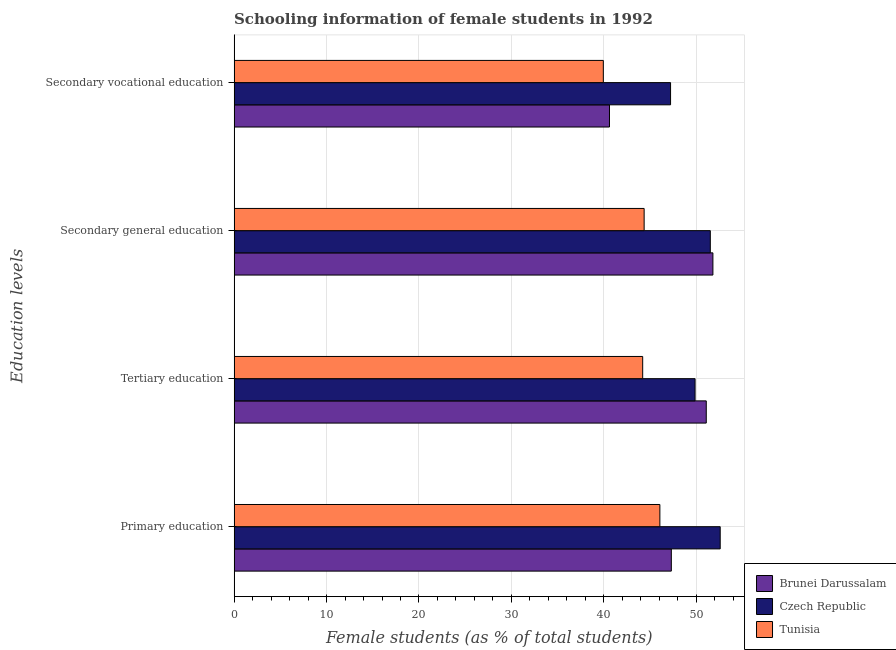How many different coloured bars are there?
Give a very brief answer. 3. How many bars are there on the 1st tick from the bottom?
Provide a succinct answer. 3. What is the percentage of female students in tertiary education in Brunei Darussalam?
Offer a terse response. 51.09. Across all countries, what is the maximum percentage of female students in secondary education?
Your response must be concise. 51.81. Across all countries, what is the minimum percentage of female students in tertiary education?
Keep it short and to the point. 44.21. In which country was the percentage of female students in tertiary education maximum?
Ensure brevity in your answer.  Brunei Darussalam. In which country was the percentage of female students in secondary education minimum?
Your answer should be very brief. Tunisia. What is the total percentage of female students in secondary education in the graph?
Your answer should be very brief. 147.7. What is the difference between the percentage of female students in tertiary education in Czech Republic and that in Tunisia?
Ensure brevity in your answer.  5.67. What is the difference between the percentage of female students in secondary education in Brunei Darussalam and the percentage of female students in primary education in Czech Republic?
Your response must be concise. -0.79. What is the average percentage of female students in secondary education per country?
Offer a very short reply. 49.23. What is the difference between the percentage of female students in secondary vocational education and percentage of female students in primary education in Czech Republic?
Offer a very short reply. -5.37. In how many countries, is the percentage of female students in secondary vocational education greater than 52 %?
Your answer should be very brief. 0. What is the ratio of the percentage of female students in secondary vocational education in Tunisia to that in Brunei Darussalam?
Offer a terse response. 0.98. Is the percentage of female students in tertiary education in Brunei Darussalam less than that in Tunisia?
Provide a succinct answer. No. Is the difference between the percentage of female students in secondary education in Brunei Darussalam and Czech Republic greater than the difference between the percentage of female students in primary education in Brunei Darussalam and Czech Republic?
Provide a succinct answer. Yes. What is the difference between the highest and the second highest percentage of female students in primary education?
Make the answer very short. 5.29. What is the difference between the highest and the lowest percentage of female students in secondary vocational education?
Your response must be concise. 7.28. What does the 1st bar from the top in Secondary general education represents?
Your response must be concise. Tunisia. What does the 3rd bar from the bottom in Tertiary education represents?
Your answer should be very brief. Tunisia. Are all the bars in the graph horizontal?
Provide a succinct answer. Yes. What is the difference between two consecutive major ticks on the X-axis?
Your answer should be compact. 10. Does the graph contain any zero values?
Your answer should be very brief. No. Where does the legend appear in the graph?
Provide a short and direct response. Bottom right. How many legend labels are there?
Provide a succinct answer. 3. What is the title of the graph?
Give a very brief answer. Schooling information of female students in 1992. What is the label or title of the X-axis?
Your answer should be very brief. Female students (as % of total students). What is the label or title of the Y-axis?
Provide a short and direct response. Education levels. What is the Female students (as % of total students) of Brunei Darussalam in Primary education?
Provide a succinct answer. 47.31. What is the Female students (as % of total students) of Czech Republic in Primary education?
Your response must be concise. 52.6. What is the Female students (as % of total students) in Tunisia in Primary education?
Offer a terse response. 46.07. What is the Female students (as % of total students) in Brunei Darussalam in Tertiary education?
Keep it short and to the point. 51.09. What is the Female students (as % of total students) of Czech Republic in Tertiary education?
Keep it short and to the point. 49.88. What is the Female students (as % of total students) in Tunisia in Tertiary education?
Offer a very short reply. 44.21. What is the Female students (as % of total students) of Brunei Darussalam in Secondary general education?
Provide a succinct answer. 51.81. What is the Female students (as % of total students) in Czech Republic in Secondary general education?
Provide a short and direct response. 51.52. What is the Female students (as % of total students) in Tunisia in Secondary general education?
Provide a short and direct response. 44.37. What is the Female students (as % of total students) of Brunei Darussalam in Secondary vocational education?
Offer a very short reply. 40.62. What is the Female students (as % of total students) in Czech Republic in Secondary vocational education?
Offer a terse response. 47.22. What is the Female students (as % of total students) in Tunisia in Secondary vocational education?
Ensure brevity in your answer.  39.95. Across all Education levels, what is the maximum Female students (as % of total students) of Brunei Darussalam?
Your answer should be very brief. 51.81. Across all Education levels, what is the maximum Female students (as % of total students) of Czech Republic?
Offer a terse response. 52.6. Across all Education levels, what is the maximum Female students (as % of total students) of Tunisia?
Ensure brevity in your answer.  46.07. Across all Education levels, what is the minimum Female students (as % of total students) of Brunei Darussalam?
Keep it short and to the point. 40.62. Across all Education levels, what is the minimum Female students (as % of total students) of Czech Republic?
Your response must be concise. 47.22. Across all Education levels, what is the minimum Female students (as % of total students) of Tunisia?
Ensure brevity in your answer.  39.95. What is the total Female students (as % of total students) in Brunei Darussalam in the graph?
Offer a very short reply. 190.82. What is the total Female students (as % of total students) in Czech Republic in the graph?
Your answer should be very brief. 201.22. What is the total Female students (as % of total students) of Tunisia in the graph?
Make the answer very short. 174.59. What is the difference between the Female students (as % of total students) of Brunei Darussalam in Primary education and that in Tertiary education?
Provide a short and direct response. -3.78. What is the difference between the Female students (as % of total students) in Czech Republic in Primary education and that in Tertiary education?
Your answer should be very brief. 2.72. What is the difference between the Female students (as % of total students) of Tunisia in Primary education and that in Tertiary education?
Ensure brevity in your answer.  1.86. What is the difference between the Female students (as % of total students) in Brunei Darussalam in Primary education and that in Secondary general education?
Provide a succinct answer. -4.5. What is the difference between the Female students (as % of total students) in Czech Republic in Primary education and that in Secondary general education?
Your answer should be compact. 1.07. What is the difference between the Female students (as % of total students) in Tunisia in Primary education and that in Secondary general education?
Provide a succinct answer. 1.7. What is the difference between the Female students (as % of total students) of Brunei Darussalam in Primary education and that in Secondary vocational education?
Provide a succinct answer. 6.69. What is the difference between the Female students (as % of total students) of Czech Republic in Primary education and that in Secondary vocational education?
Your answer should be very brief. 5.37. What is the difference between the Female students (as % of total students) in Tunisia in Primary education and that in Secondary vocational education?
Keep it short and to the point. 6.12. What is the difference between the Female students (as % of total students) in Brunei Darussalam in Tertiary education and that in Secondary general education?
Your answer should be compact. -0.72. What is the difference between the Female students (as % of total students) of Czech Republic in Tertiary education and that in Secondary general education?
Make the answer very short. -1.65. What is the difference between the Female students (as % of total students) in Tunisia in Tertiary education and that in Secondary general education?
Your answer should be very brief. -0.16. What is the difference between the Female students (as % of total students) of Brunei Darussalam in Tertiary education and that in Secondary vocational education?
Your response must be concise. 10.47. What is the difference between the Female students (as % of total students) in Czech Republic in Tertiary education and that in Secondary vocational education?
Make the answer very short. 2.65. What is the difference between the Female students (as % of total students) in Tunisia in Tertiary education and that in Secondary vocational education?
Offer a terse response. 4.26. What is the difference between the Female students (as % of total students) of Brunei Darussalam in Secondary general education and that in Secondary vocational education?
Your response must be concise. 11.19. What is the difference between the Female students (as % of total students) in Czech Republic in Secondary general education and that in Secondary vocational education?
Provide a succinct answer. 4.3. What is the difference between the Female students (as % of total students) in Tunisia in Secondary general education and that in Secondary vocational education?
Provide a short and direct response. 4.42. What is the difference between the Female students (as % of total students) in Brunei Darussalam in Primary education and the Female students (as % of total students) in Czech Republic in Tertiary education?
Provide a short and direct response. -2.57. What is the difference between the Female students (as % of total students) of Brunei Darussalam in Primary education and the Female students (as % of total students) of Tunisia in Tertiary education?
Ensure brevity in your answer.  3.1. What is the difference between the Female students (as % of total students) in Czech Republic in Primary education and the Female students (as % of total students) in Tunisia in Tertiary education?
Provide a succinct answer. 8.39. What is the difference between the Female students (as % of total students) of Brunei Darussalam in Primary education and the Female students (as % of total students) of Czech Republic in Secondary general education?
Make the answer very short. -4.22. What is the difference between the Female students (as % of total students) in Brunei Darussalam in Primary education and the Female students (as % of total students) in Tunisia in Secondary general education?
Offer a very short reply. 2.94. What is the difference between the Female students (as % of total students) of Czech Republic in Primary education and the Female students (as % of total students) of Tunisia in Secondary general education?
Keep it short and to the point. 8.23. What is the difference between the Female students (as % of total students) in Brunei Darussalam in Primary education and the Female students (as % of total students) in Czech Republic in Secondary vocational education?
Provide a short and direct response. 0.08. What is the difference between the Female students (as % of total students) in Brunei Darussalam in Primary education and the Female students (as % of total students) in Tunisia in Secondary vocational education?
Offer a terse response. 7.36. What is the difference between the Female students (as % of total students) in Czech Republic in Primary education and the Female students (as % of total students) in Tunisia in Secondary vocational education?
Offer a terse response. 12.65. What is the difference between the Female students (as % of total students) in Brunei Darussalam in Tertiary education and the Female students (as % of total students) in Czech Republic in Secondary general education?
Your answer should be very brief. -0.44. What is the difference between the Female students (as % of total students) of Brunei Darussalam in Tertiary education and the Female students (as % of total students) of Tunisia in Secondary general education?
Provide a succinct answer. 6.72. What is the difference between the Female students (as % of total students) in Czech Republic in Tertiary education and the Female students (as % of total students) in Tunisia in Secondary general education?
Keep it short and to the point. 5.51. What is the difference between the Female students (as % of total students) in Brunei Darussalam in Tertiary education and the Female students (as % of total students) in Czech Republic in Secondary vocational education?
Keep it short and to the point. 3.86. What is the difference between the Female students (as % of total students) of Brunei Darussalam in Tertiary education and the Female students (as % of total students) of Tunisia in Secondary vocational education?
Your answer should be very brief. 11.14. What is the difference between the Female students (as % of total students) of Czech Republic in Tertiary education and the Female students (as % of total students) of Tunisia in Secondary vocational education?
Your answer should be very brief. 9.93. What is the difference between the Female students (as % of total students) of Brunei Darussalam in Secondary general education and the Female students (as % of total students) of Czech Republic in Secondary vocational education?
Provide a succinct answer. 4.58. What is the difference between the Female students (as % of total students) in Brunei Darussalam in Secondary general education and the Female students (as % of total students) in Tunisia in Secondary vocational education?
Provide a succinct answer. 11.86. What is the difference between the Female students (as % of total students) of Czech Republic in Secondary general education and the Female students (as % of total students) of Tunisia in Secondary vocational education?
Your answer should be very brief. 11.57. What is the average Female students (as % of total students) of Brunei Darussalam per Education levels?
Your answer should be very brief. 47.7. What is the average Female students (as % of total students) in Czech Republic per Education levels?
Keep it short and to the point. 50.31. What is the average Female students (as % of total students) of Tunisia per Education levels?
Keep it short and to the point. 43.65. What is the difference between the Female students (as % of total students) of Brunei Darussalam and Female students (as % of total students) of Czech Republic in Primary education?
Offer a very short reply. -5.29. What is the difference between the Female students (as % of total students) in Brunei Darussalam and Female students (as % of total students) in Tunisia in Primary education?
Offer a terse response. 1.24. What is the difference between the Female students (as % of total students) in Czech Republic and Female students (as % of total students) in Tunisia in Primary education?
Offer a terse response. 6.53. What is the difference between the Female students (as % of total students) in Brunei Darussalam and Female students (as % of total students) in Czech Republic in Tertiary education?
Ensure brevity in your answer.  1.21. What is the difference between the Female students (as % of total students) in Brunei Darussalam and Female students (as % of total students) in Tunisia in Tertiary education?
Your answer should be very brief. 6.88. What is the difference between the Female students (as % of total students) of Czech Republic and Female students (as % of total students) of Tunisia in Tertiary education?
Ensure brevity in your answer.  5.67. What is the difference between the Female students (as % of total students) in Brunei Darussalam and Female students (as % of total students) in Czech Republic in Secondary general education?
Offer a very short reply. 0.28. What is the difference between the Female students (as % of total students) of Brunei Darussalam and Female students (as % of total students) of Tunisia in Secondary general education?
Offer a terse response. 7.44. What is the difference between the Female students (as % of total students) of Czech Republic and Female students (as % of total students) of Tunisia in Secondary general education?
Ensure brevity in your answer.  7.16. What is the difference between the Female students (as % of total students) in Brunei Darussalam and Female students (as % of total students) in Czech Republic in Secondary vocational education?
Your answer should be very brief. -6.61. What is the difference between the Female students (as % of total students) in Brunei Darussalam and Female students (as % of total students) in Tunisia in Secondary vocational education?
Ensure brevity in your answer.  0.67. What is the difference between the Female students (as % of total students) in Czech Republic and Female students (as % of total students) in Tunisia in Secondary vocational education?
Make the answer very short. 7.28. What is the ratio of the Female students (as % of total students) in Brunei Darussalam in Primary education to that in Tertiary education?
Your answer should be compact. 0.93. What is the ratio of the Female students (as % of total students) in Czech Republic in Primary education to that in Tertiary education?
Provide a succinct answer. 1.05. What is the ratio of the Female students (as % of total students) of Tunisia in Primary education to that in Tertiary education?
Keep it short and to the point. 1.04. What is the ratio of the Female students (as % of total students) of Brunei Darussalam in Primary education to that in Secondary general education?
Make the answer very short. 0.91. What is the ratio of the Female students (as % of total students) in Czech Republic in Primary education to that in Secondary general education?
Ensure brevity in your answer.  1.02. What is the ratio of the Female students (as % of total students) of Tunisia in Primary education to that in Secondary general education?
Make the answer very short. 1.04. What is the ratio of the Female students (as % of total students) in Brunei Darussalam in Primary education to that in Secondary vocational education?
Ensure brevity in your answer.  1.16. What is the ratio of the Female students (as % of total students) of Czech Republic in Primary education to that in Secondary vocational education?
Offer a terse response. 1.11. What is the ratio of the Female students (as % of total students) of Tunisia in Primary education to that in Secondary vocational education?
Your answer should be compact. 1.15. What is the ratio of the Female students (as % of total students) of Brunei Darussalam in Tertiary education to that in Secondary general education?
Ensure brevity in your answer.  0.99. What is the ratio of the Female students (as % of total students) of Czech Republic in Tertiary education to that in Secondary general education?
Your response must be concise. 0.97. What is the ratio of the Female students (as % of total students) in Brunei Darussalam in Tertiary education to that in Secondary vocational education?
Your response must be concise. 1.26. What is the ratio of the Female students (as % of total students) of Czech Republic in Tertiary education to that in Secondary vocational education?
Offer a terse response. 1.06. What is the ratio of the Female students (as % of total students) of Tunisia in Tertiary education to that in Secondary vocational education?
Make the answer very short. 1.11. What is the ratio of the Female students (as % of total students) of Brunei Darussalam in Secondary general education to that in Secondary vocational education?
Give a very brief answer. 1.28. What is the ratio of the Female students (as % of total students) of Czech Republic in Secondary general education to that in Secondary vocational education?
Ensure brevity in your answer.  1.09. What is the ratio of the Female students (as % of total students) of Tunisia in Secondary general education to that in Secondary vocational education?
Keep it short and to the point. 1.11. What is the difference between the highest and the second highest Female students (as % of total students) in Brunei Darussalam?
Your answer should be compact. 0.72. What is the difference between the highest and the second highest Female students (as % of total students) of Czech Republic?
Offer a terse response. 1.07. What is the difference between the highest and the second highest Female students (as % of total students) in Tunisia?
Provide a succinct answer. 1.7. What is the difference between the highest and the lowest Female students (as % of total students) in Brunei Darussalam?
Ensure brevity in your answer.  11.19. What is the difference between the highest and the lowest Female students (as % of total students) of Czech Republic?
Keep it short and to the point. 5.37. What is the difference between the highest and the lowest Female students (as % of total students) of Tunisia?
Ensure brevity in your answer.  6.12. 